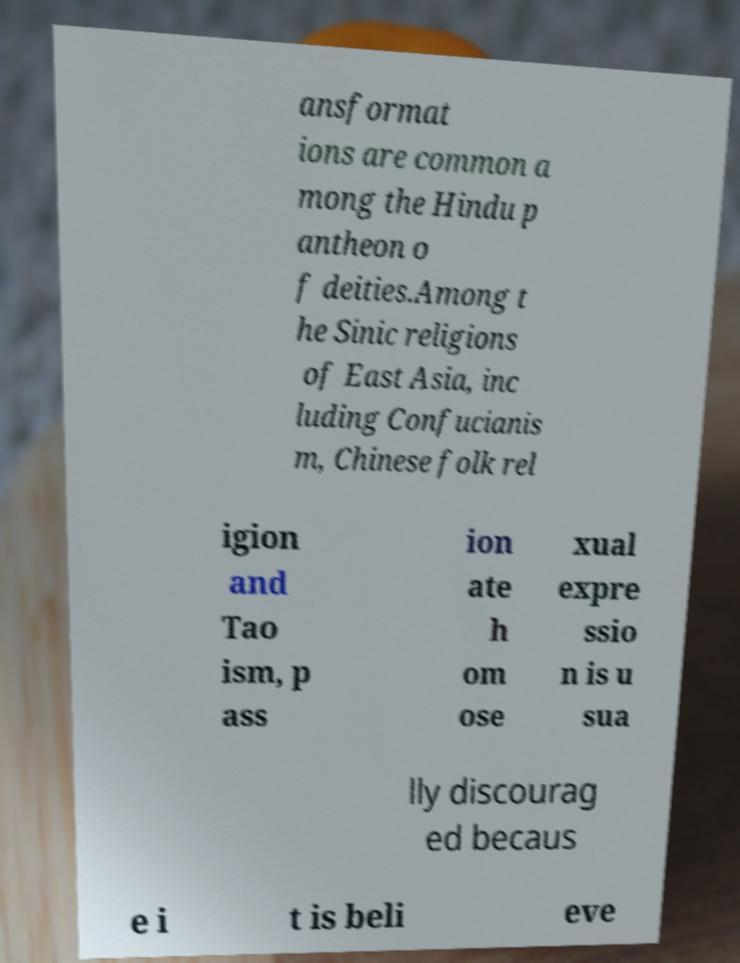Could you extract and type out the text from this image? ansformat ions are common a mong the Hindu p antheon o f deities.Among t he Sinic religions of East Asia, inc luding Confucianis m, Chinese folk rel igion and Tao ism, p ass ion ate h om ose xual expre ssio n is u sua lly discourag ed becaus e i t is beli eve 